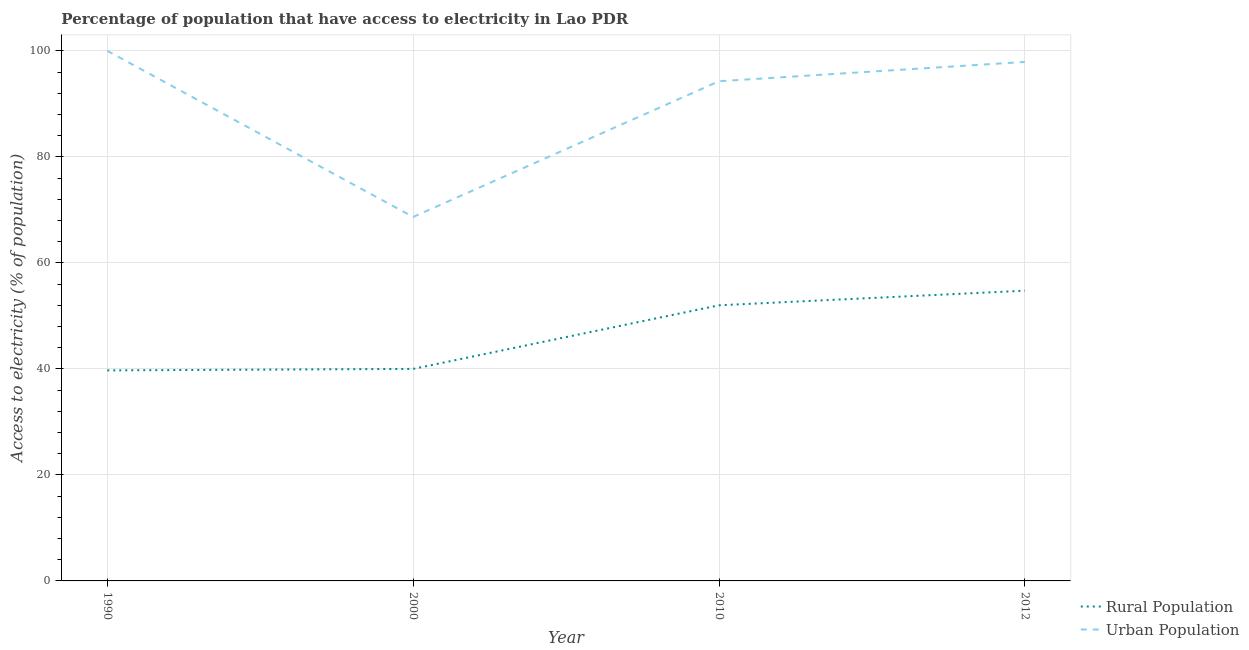Does the line corresponding to percentage of urban population having access to electricity intersect with the line corresponding to percentage of rural population having access to electricity?
Provide a short and direct response. No. What is the percentage of rural population having access to electricity in 1990?
Keep it short and to the point. 39.72. Across all years, what is the maximum percentage of rural population having access to electricity?
Offer a terse response. 54.75. Across all years, what is the minimum percentage of rural population having access to electricity?
Keep it short and to the point. 39.72. In which year was the percentage of rural population having access to electricity maximum?
Ensure brevity in your answer.  2012. What is the total percentage of urban population having access to electricity in the graph?
Offer a very short reply. 360.85. What is the difference between the percentage of urban population having access to electricity in 2000 and that in 2010?
Provide a succinct answer. -25.6. What is the difference between the percentage of urban population having access to electricity in 2010 and the percentage of rural population having access to electricity in 2012?
Ensure brevity in your answer.  39.51. What is the average percentage of urban population having access to electricity per year?
Ensure brevity in your answer.  90.21. In the year 2000, what is the difference between the percentage of rural population having access to electricity and percentage of urban population having access to electricity?
Your answer should be compact. -28.67. In how many years, is the percentage of rural population having access to electricity greater than 68 %?
Make the answer very short. 0. What is the ratio of the percentage of rural population having access to electricity in 1990 to that in 2000?
Provide a short and direct response. 0.99. What is the difference between the highest and the second highest percentage of rural population having access to electricity?
Make the answer very short. 2.75. What is the difference between the highest and the lowest percentage of rural population having access to electricity?
Give a very brief answer. 15.03. In how many years, is the percentage of rural population having access to electricity greater than the average percentage of rural population having access to electricity taken over all years?
Ensure brevity in your answer.  2. How many lines are there?
Provide a succinct answer. 2. How many years are there in the graph?
Offer a terse response. 4. What is the difference between two consecutive major ticks on the Y-axis?
Ensure brevity in your answer.  20. Does the graph contain any zero values?
Provide a short and direct response. No. Where does the legend appear in the graph?
Offer a terse response. Bottom right. How many legend labels are there?
Your answer should be very brief. 2. How are the legend labels stacked?
Keep it short and to the point. Vertical. What is the title of the graph?
Your answer should be very brief. Percentage of population that have access to electricity in Lao PDR. What is the label or title of the X-axis?
Offer a very short reply. Year. What is the label or title of the Y-axis?
Provide a short and direct response. Access to electricity (% of population). What is the Access to electricity (% of population) in Rural Population in 1990?
Your answer should be very brief. 39.72. What is the Access to electricity (% of population) in Rural Population in 2000?
Ensure brevity in your answer.  40. What is the Access to electricity (% of population) of Urban Population in 2000?
Give a very brief answer. 68.67. What is the Access to electricity (% of population) of Urban Population in 2010?
Provide a succinct answer. 94.27. What is the Access to electricity (% of population) of Rural Population in 2012?
Make the answer very short. 54.75. What is the Access to electricity (% of population) of Urban Population in 2012?
Ensure brevity in your answer.  97.91. Across all years, what is the maximum Access to electricity (% of population) of Rural Population?
Provide a succinct answer. 54.75. Across all years, what is the minimum Access to electricity (% of population) in Rural Population?
Provide a short and direct response. 39.72. Across all years, what is the minimum Access to electricity (% of population) of Urban Population?
Make the answer very short. 68.67. What is the total Access to electricity (% of population) of Rural Population in the graph?
Give a very brief answer. 186.47. What is the total Access to electricity (% of population) of Urban Population in the graph?
Give a very brief answer. 360.85. What is the difference between the Access to electricity (% of population) in Rural Population in 1990 and that in 2000?
Your answer should be compact. -0.28. What is the difference between the Access to electricity (% of population) of Urban Population in 1990 and that in 2000?
Your answer should be very brief. 31.33. What is the difference between the Access to electricity (% of population) of Rural Population in 1990 and that in 2010?
Provide a short and direct response. -12.28. What is the difference between the Access to electricity (% of population) of Urban Population in 1990 and that in 2010?
Your answer should be compact. 5.73. What is the difference between the Access to electricity (% of population) of Rural Population in 1990 and that in 2012?
Your answer should be compact. -15.03. What is the difference between the Access to electricity (% of population) in Urban Population in 1990 and that in 2012?
Give a very brief answer. 2.09. What is the difference between the Access to electricity (% of population) of Rural Population in 2000 and that in 2010?
Make the answer very short. -12. What is the difference between the Access to electricity (% of population) in Urban Population in 2000 and that in 2010?
Offer a terse response. -25.6. What is the difference between the Access to electricity (% of population) in Rural Population in 2000 and that in 2012?
Make the answer very short. -14.75. What is the difference between the Access to electricity (% of population) of Urban Population in 2000 and that in 2012?
Offer a very short reply. -29.25. What is the difference between the Access to electricity (% of population) in Rural Population in 2010 and that in 2012?
Ensure brevity in your answer.  -2.75. What is the difference between the Access to electricity (% of population) of Urban Population in 2010 and that in 2012?
Provide a succinct answer. -3.64. What is the difference between the Access to electricity (% of population) in Rural Population in 1990 and the Access to electricity (% of population) in Urban Population in 2000?
Your response must be concise. -28.95. What is the difference between the Access to electricity (% of population) in Rural Population in 1990 and the Access to electricity (% of population) in Urban Population in 2010?
Make the answer very short. -54.55. What is the difference between the Access to electricity (% of population) of Rural Population in 1990 and the Access to electricity (% of population) of Urban Population in 2012?
Ensure brevity in your answer.  -58.19. What is the difference between the Access to electricity (% of population) in Rural Population in 2000 and the Access to electricity (% of population) in Urban Population in 2010?
Give a very brief answer. -54.27. What is the difference between the Access to electricity (% of population) of Rural Population in 2000 and the Access to electricity (% of population) of Urban Population in 2012?
Give a very brief answer. -57.91. What is the difference between the Access to electricity (% of population) of Rural Population in 2010 and the Access to electricity (% of population) of Urban Population in 2012?
Your answer should be compact. -45.91. What is the average Access to electricity (% of population) in Rural Population per year?
Your response must be concise. 46.62. What is the average Access to electricity (% of population) in Urban Population per year?
Ensure brevity in your answer.  90.21. In the year 1990, what is the difference between the Access to electricity (% of population) of Rural Population and Access to electricity (% of population) of Urban Population?
Provide a short and direct response. -60.28. In the year 2000, what is the difference between the Access to electricity (% of population) in Rural Population and Access to electricity (% of population) in Urban Population?
Provide a succinct answer. -28.67. In the year 2010, what is the difference between the Access to electricity (% of population) of Rural Population and Access to electricity (% of population) of Urban Population?
Provide a short and direct response. -42.27. In the year 2012, what is the difference between the Access to electricity (% of population) of Rural Population and Access to electricity (% of population) of Urban Population?
Offer a terse response. -43.16. What is the ratio of the Access to electricity (% of population) in Rural Population in 1990 to that in 2000?
Provide a succinct answer. 0.99. What is the ratio of the Access to electricity (% of population) in Urban Population in 1990 to that in 2000?
Give a very brief answer. 1.46. What is the ratio of the Access to electricity (% of population) in Rural Population in 1990 to that in 2010?
Your response must be concise. 0.76. What is the ratio of the Access to electricity (% of population) of Urban Population in 1990 to that in 2010?
Your response must be concise. 1.06. What is the ratio of the Access to electricity (% of population) of Rural Population in 1990 to that in 2012?
Ensure brevity in your answer.  0.73. What is the ratio of the Access to electricity (% of population) in Urban Population in 1990 to that in 2012?
Keep it short and to the point. 1.02. What is the ratio of the Access to electricity (% of population) of Rural Population in 2000 to that in 2010?
Ensure brevity in your answer.  0.77. What is the ratio of the Access to electricity (% of population) of Urban Population in 2000 to that in 2010?
Your response must be concise. 0.73. What is the ratio of the Access to electricity (% of population) in Rural Population in 2000 to that in 2012?
Your answer should be very brief. 0.73. What is the ratio of the Access to electricity (% of population) of Urban Population in 2000 to that in 2012?
Provide a short and direct response. 0.7. What is the ratio of the Access to electricity (% of population) of Rural Population in 2010 to that in 2012?
Provide a succinct answer. 0.95. What is the ratio of the Access to electricity (% of population) in Urban Population in 2010 to that in 2012?
Provide a short and direct response. 0.96. What is the difference between the highest and the second highest Access to electricity (% of population) in Rural Population?
Offer a very short reply. 2.75. What is the difference between the highest and the second highest Access to electricity (% of population) of Urban Population?
Provide a short and direct response. 2.09. What is the difference between the highest and the lowest Access to electricity (% of population) of Rural Population?
Keep it short and to the point. 15.03. What is the difference between the highest and the lowest Access to electricity (% of population) in Urban Population?
Provide a short and direct response. 31.33. 